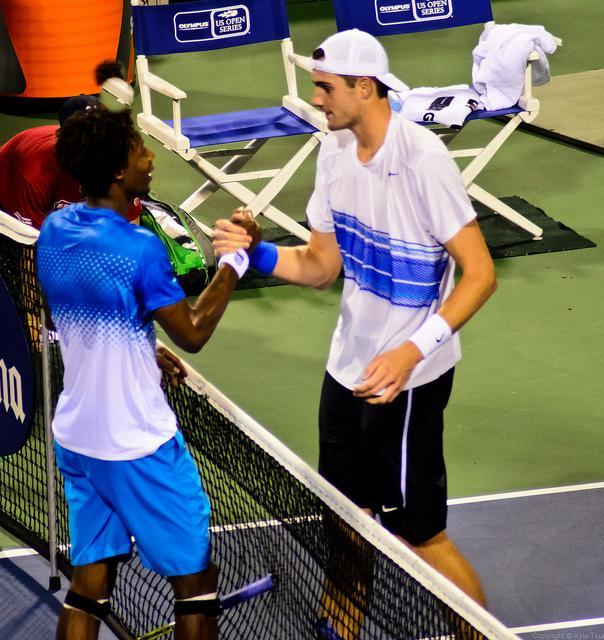Why have the two men gripped hands? Please explain your reasoning. showing respect. These two athletes shake hands over the net which they have or will presumably compete against one another. 